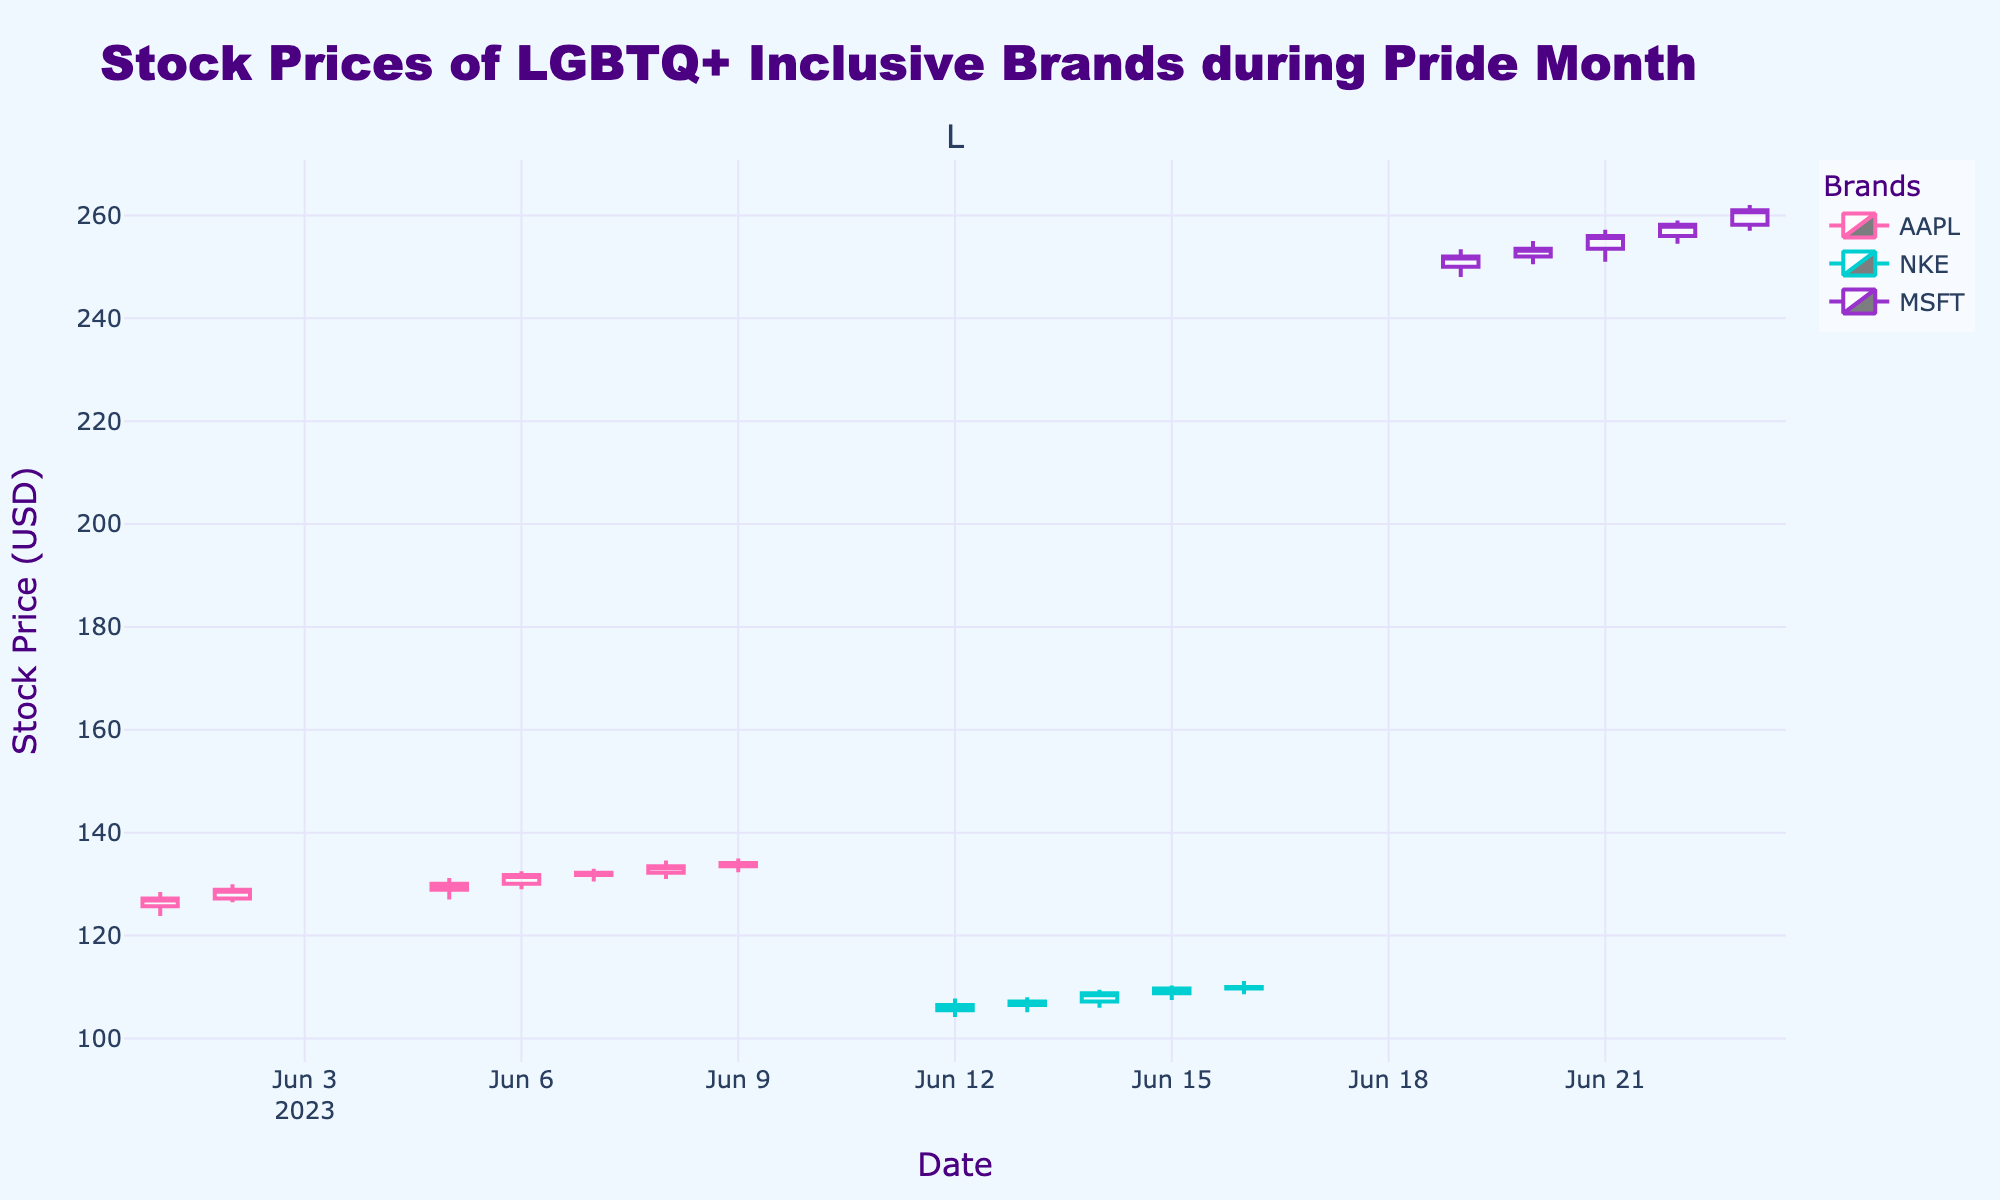How many different companies' stock prices are displayed in the plot? The figure's legend shows three companies: AAPL, NKE, and MSFT. Each company's stock prices are represented in the plot with different colors.
Answer: Three What is the highest closing price for AAPL in June? By examining AAPL's candlestick series, we identify that the highest closing price is on June 9, with a close value of 134.10.
Answer: 134.10 Which company's stocks had the highest volume on June 7? We need to look at the volume values for June 7 in the data and find the highest among AAPL, NKE, and MSFT. AAPL had a volume of 40,098,200, which is highest since NKE and MSFT are not represented on that day.
Answer: AAPL How does MSFT's closing price on June 23 compare to its opening price? For June 23, compare MSFT’s opening price (258.20) to its closing price (261.00). We see that the closing price is higher than the opening price.
Answer: Higher What's the average closing price of NKE in mid-June (June 12 to June 16)? Sum the closing prices of NKE from June 12 to June 16: (106.50 + 107.20 + 108.80 + 109.70 + 110.00) = 542.2, then divide by 5 days for the average: 542.2 / 5 = 108.44.
Answer: 108.44 Which company's stock showed an increasing trend throughout the week of June 19 to June 23? Examine the closing prices of all companies between June 19 to June 23. Only MSFT is available during this week, and its closing prices kept increasing: 252.00 → 253.50 → 256.00 → 258.20 → 261.00.
Answer: MSFT For which company is the difference between the highest and lowest prices the largest in June? Calculate the range (high - low) for each company:
- AAPL: highest (134.60) - lowest (123.80) = 10.80
- NKE: highest (111.20) - lowest (104.20) = 7.00
- MSFT: highest (262.00) - lowest (248.00) = 14.00
MSFT has the largest difference.
Answer: MSFT What is the color representing NKE’s stock in the plot? The figure legend indicates NKE's stock is represented with a specific color. Observing the legend, NKE's color is shown as light blue (cyan).
Answer: Light blue (cyan) How many trading days does the plot cover for AAPL in June? Count the number of candlesticks representing AAPL in the plot. AAPL is shown from June 1 to June 9, totaling 7 trading days excluding weekends.
Answer: 7 During which week did AAPL experience the most significant upward trend? Compare AAPL's weekly closing prices over the given period: The week of June 5 to June 9 shows a clear upward trend from 128.90 to 134.10.
Answer: Week of June 5 to June 9 